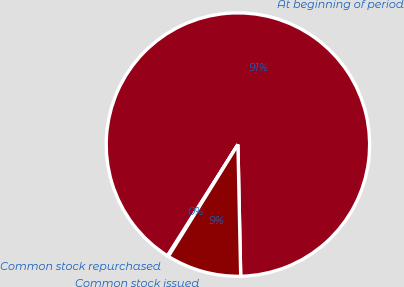Convert chart to OTSL. <chart><loc_0><loc_0><loc_500><loc_500><pie_chart><fcel>At beginning of period<fcel>Common stock repurchased<fcel>Common stock issued<nl><fcel>90.69%<fcel>0.13%<fcel>9.19%<nl></chart> 